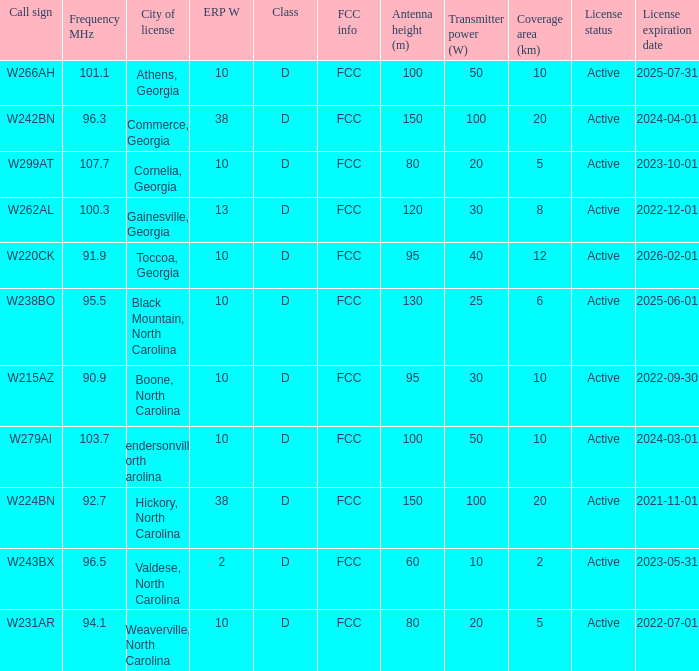What class is the city of black mountain, north carolina? D. 